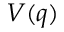<formula> <loc_0><loc_0><loc_500><loc_500>V ( q )</formula> 